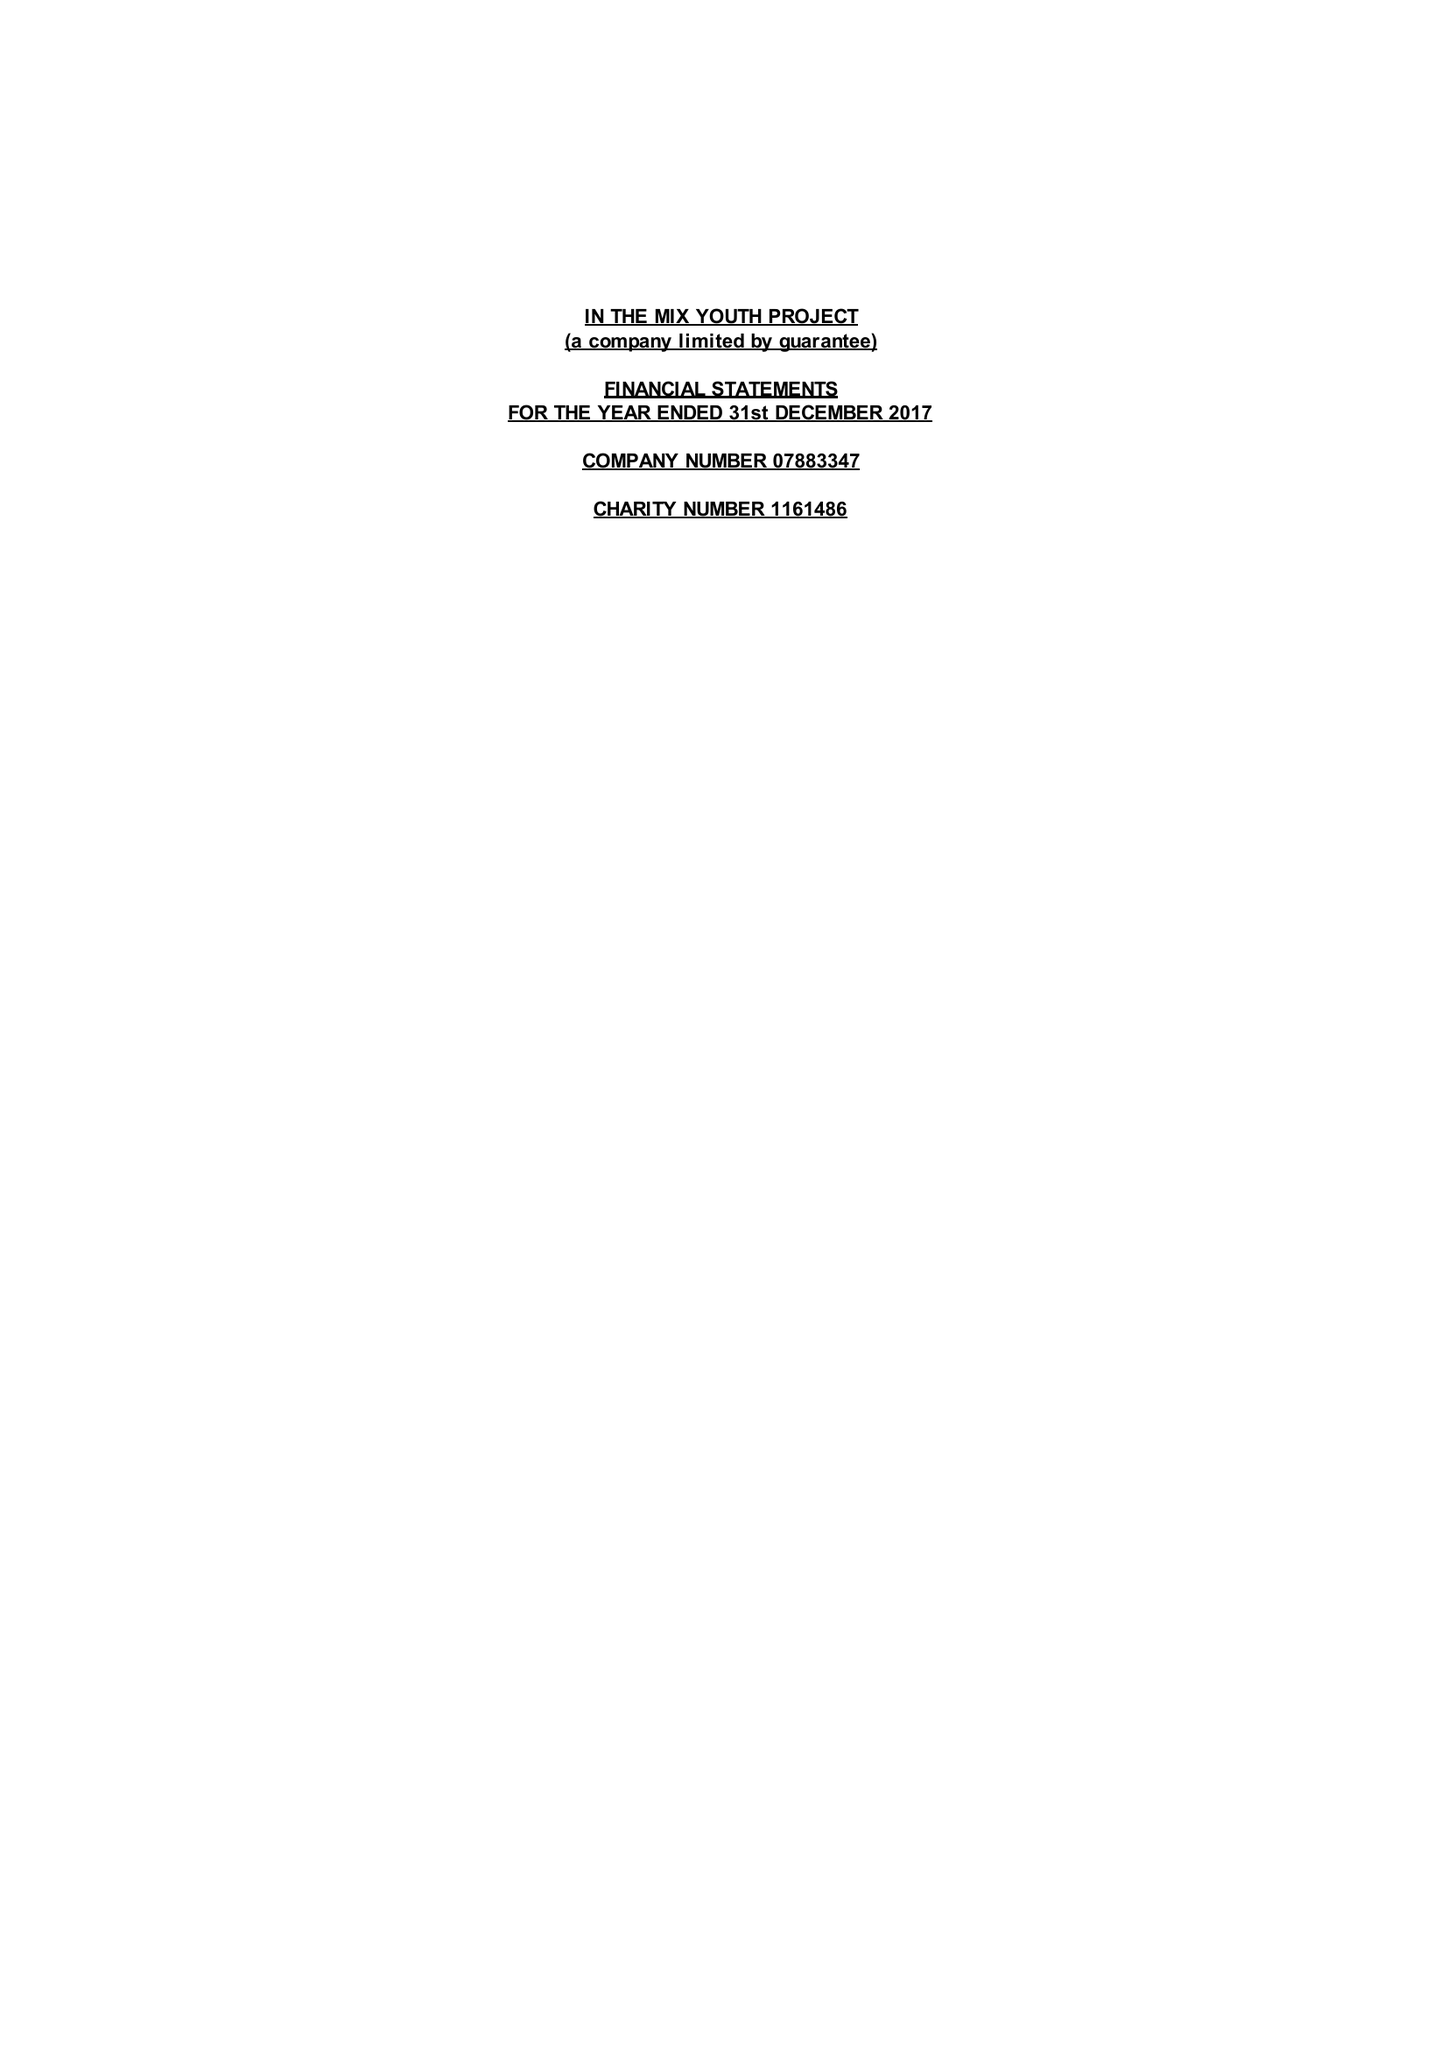What is the value for the report_date?
Answer the question using a single word or phrase. 2017-12-31 